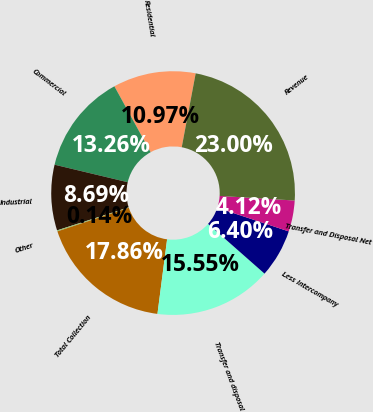Convert chart to OTSL. <chart><loc_0><loc_0><loc_500><loc_500><pie_chart><fcel>Residential<fcel>Commercial<fcel>Industrial<fcel>Other<fcel>Total Collection<fcel>Transfer and disposal<fcel>Less Intercompany<fcel>Transfer and Disposal Net<fcel>Revenue<nl><fcel>10.97%<fcel>13.26%<fcel>8.69%<fcel>0.14%<fcel>17.86%<fcel>15.55%<fcel>6.4%<fcel>4.12%<fcel>23.0%<nl></chart> 